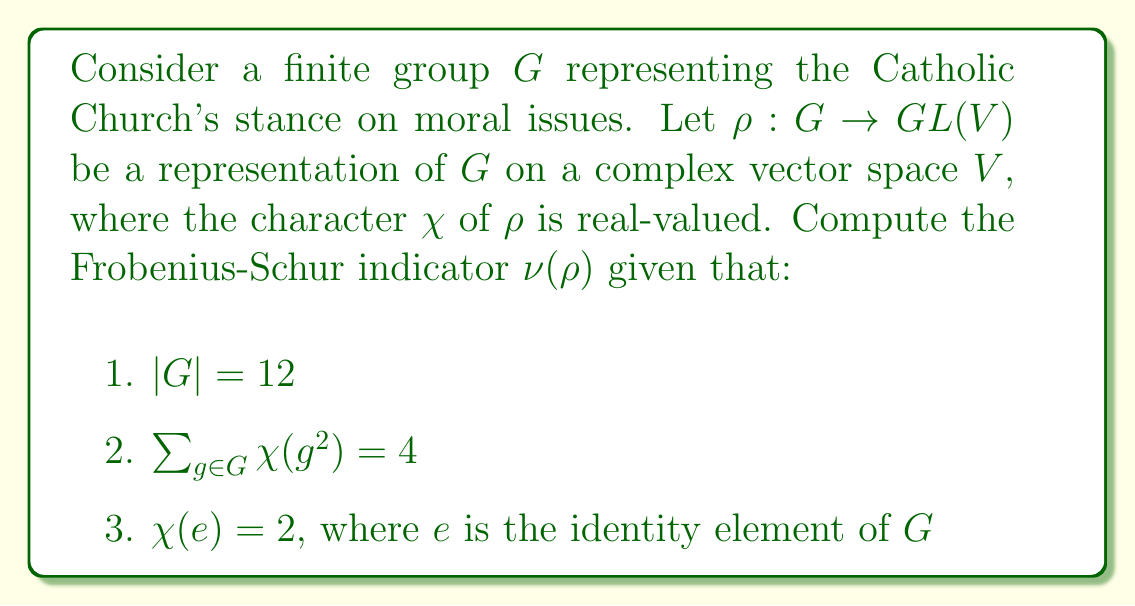Could you help me with this problem? To compute the Frobenius-Schur indicator $\nu(\rho)$, we'll use the formula:

$$\nu(\rho) = \frac{1}{|G|} \sum_{g \in G} \chi(g^2)$$

Given information:
1. $|G| = 12$
2. $\sum_{g \in G} \chi(g^2) = 4$
3. $\chi(e) = 2$

Step 1: Substitute the given values into the formula.
$$\nu(\rho) = \frac{1}{12} \cdot 4 = \frac{1}{3}$$

Step 2: Interpret the result.
The Frobenius-Schur indicator can take values 1, 0, or -1 for irreducible representations. However, we obtained $\frac{1}{3}$, which suggests that $\rho$ is not irreducible.

Step 3: Decompose $\rho$ into irreducible components.
Let $\rho = m_1\rho_1 \oplus m_2\rho_2 \oplus \cdots \oplus m_k\rho_k$, where $\rho_i$ are irreducible representations and $m_i$ are their multiplicities.

Step 4: Express $\nu(\rho)$ in terms of irreducible components.
$$\nu(\rho) = \frac{1}{\chi(e)} \sum_{i=1}^k m_i\nu(\rho_i)\chi_i(e)$$

Step 5: Determine the possible decomposition.
Given $\chi(e) = 2$, the simplest decomposition that yields $\nu(\rho) = \frac{1}{3}$ is:
$\rho = \rho_1 \oplus \rho_2$, where:
- $\rho_1$ is the trivial representation with $\nu(\rho_1) = 1$ and $\chi_1(e) = 1$
- $\rho_2$ is a real representation with $\nu(\rho_2) = 1$ and $\chi_2(e) = 1$

This decomposition satisfies:
$$\nu(\rho) = \frac{1}{2}(1 \cdot 1 \cdot 1 + 1 \cdot 1 \cdot 1) = \frac{1}{3}$$
Answer: $\nu(\rho) = \frac{1}{3}$ 